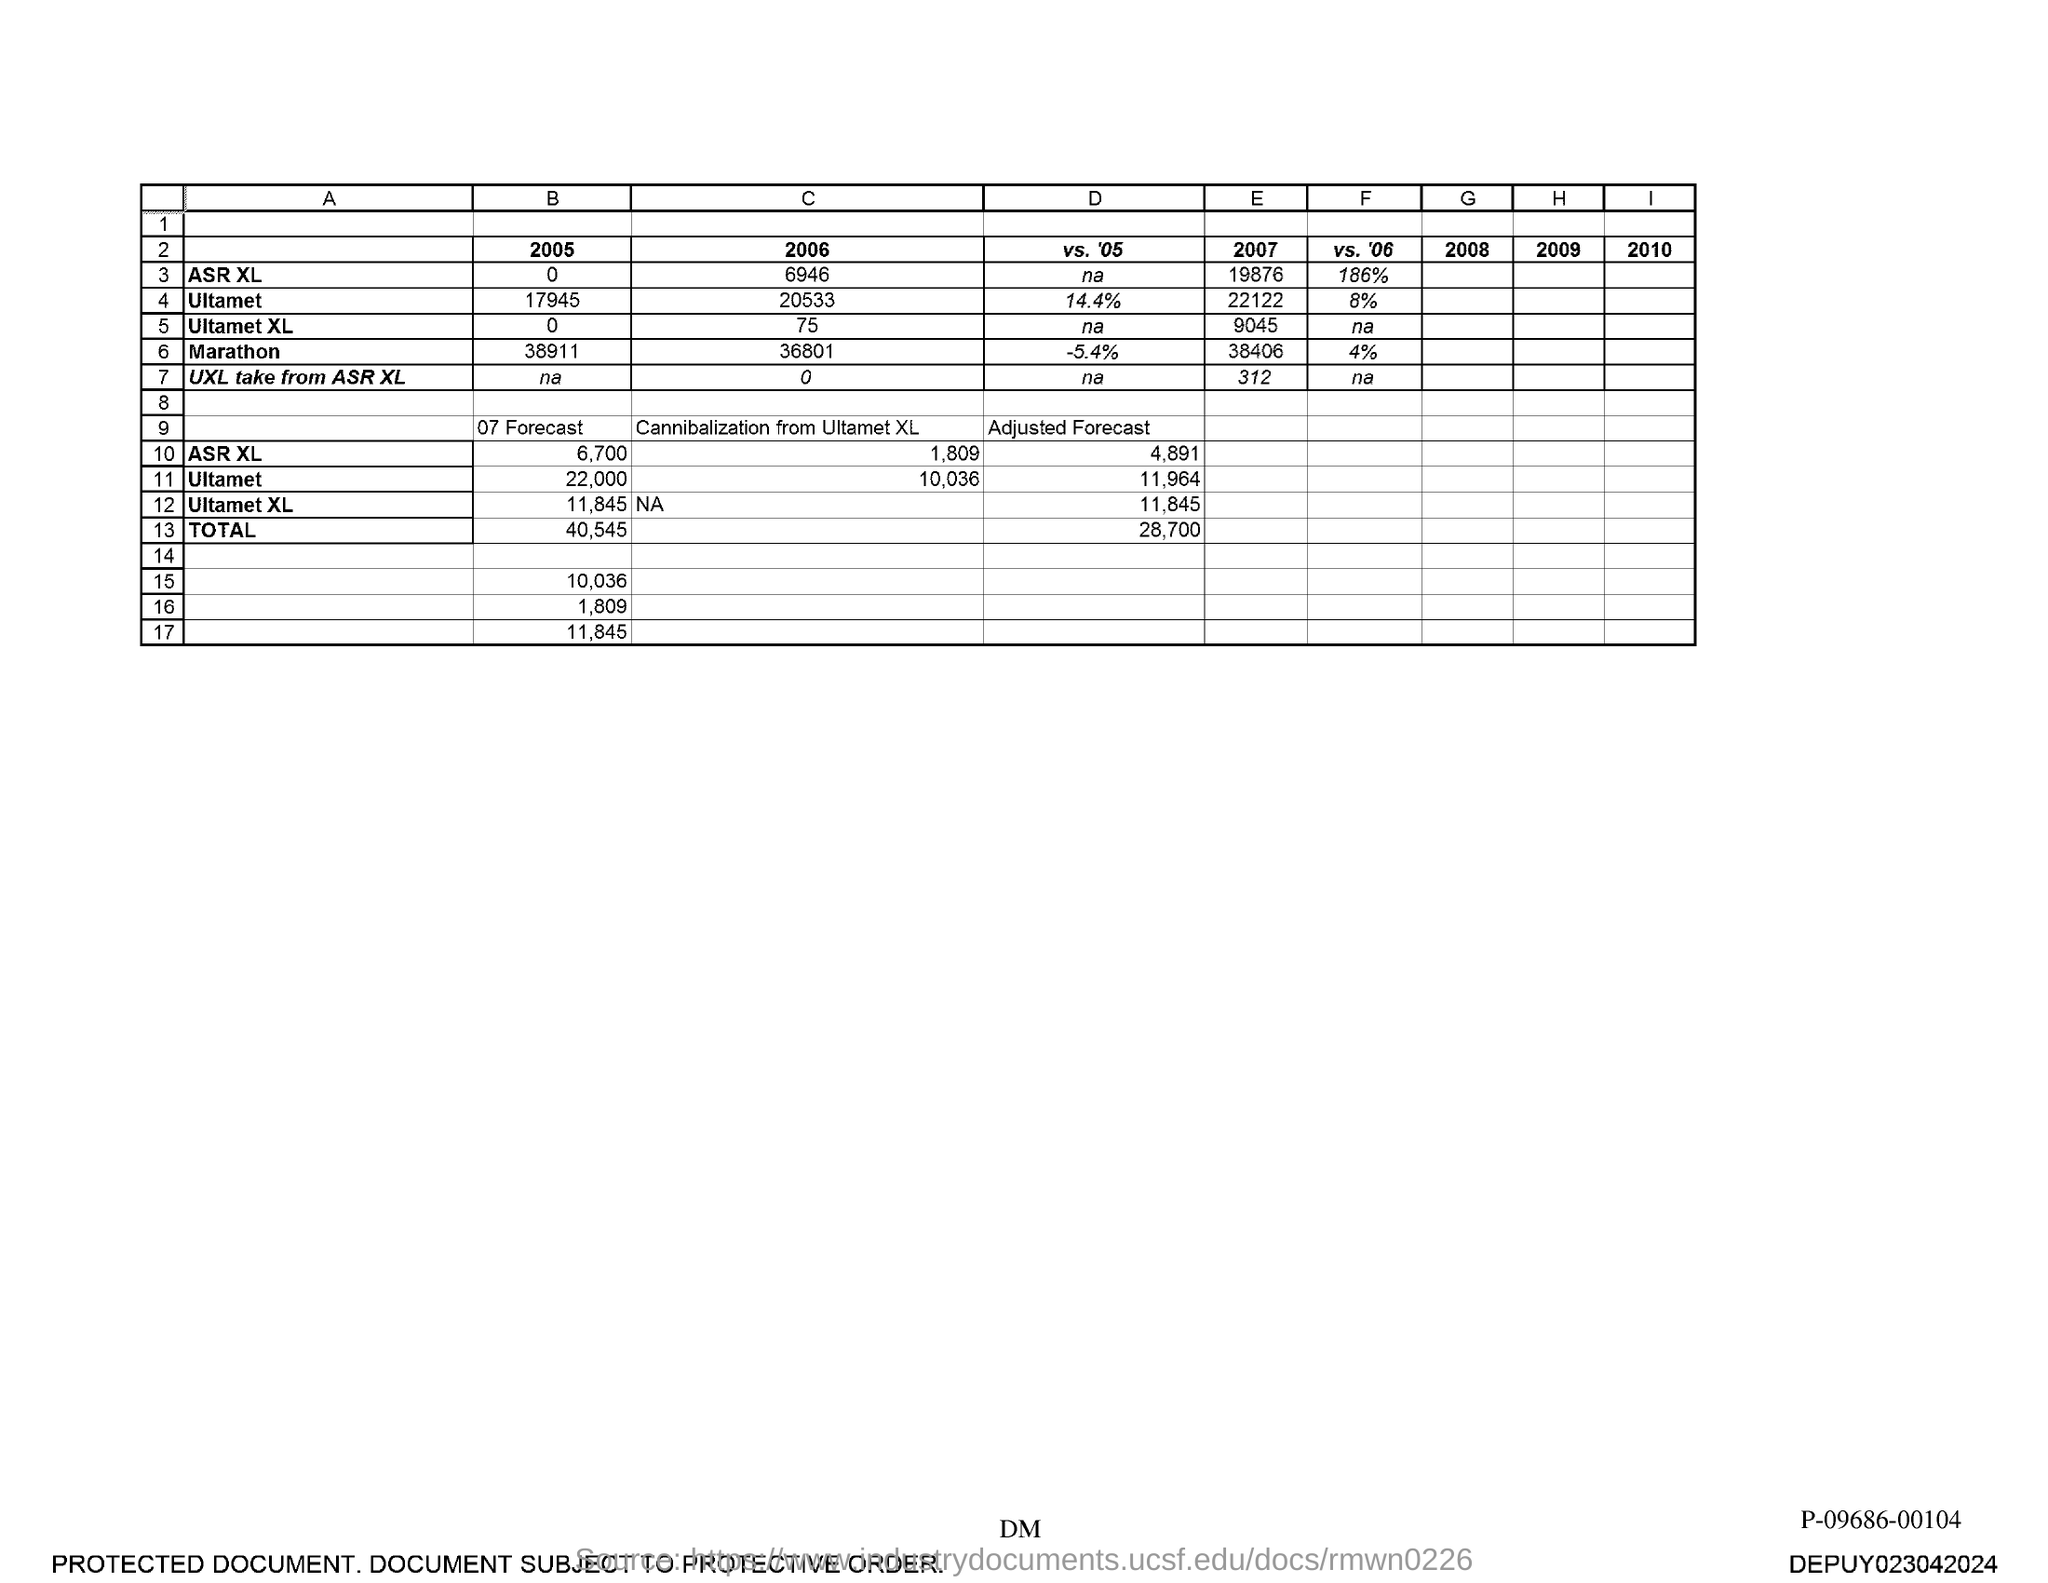Draw attention to some important aspects in this diagram. The adjusted forecast for ASR XL is expected to be 4,891. 